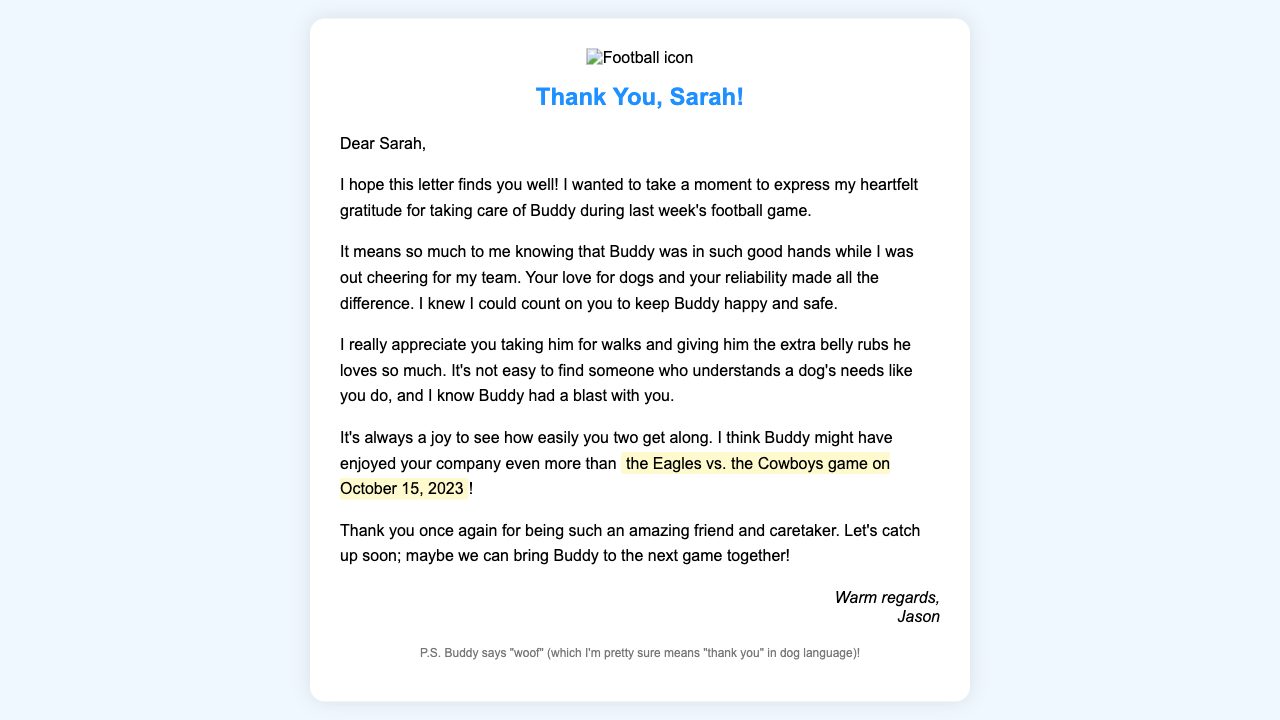What is the name of the recipient? The recipient's name is specifically mentioned in the greeting of the letter.
Answer: Sarah Who is the author of the letter? The author introduces himself at the bottom of the letter before the signature.
Answer: Jason What was the date of the football game? The date of the football game is explicitly included in the text.
Answer: October 15, 2023 What is the name of the author's dog? The author's dog is referred to several times in the document.
Answer: Buddy What did the author appreciate the most about Sarah? The author expresses his feelings regarding Sarah's treatment of Buddy in the letter.
Answer: Reliability What activity did Sarah do with Buddy? The text mentions specific actions that Sarah took care of while looking after Buddy.
Answer: Walks How did the author feel knowing Buddy was taken care of? The author conveys his sentiments about the situation in the letter.
Answer: Grateful What is the author's hope expressed towards the end of the letter? The author expresses a hope for a future meeting, implying a social outing.
Answer: Catch up soon What does Buddy say in the postscript? The author writes down what Buddy supposedly says in dog language.
Answer: "woof" 